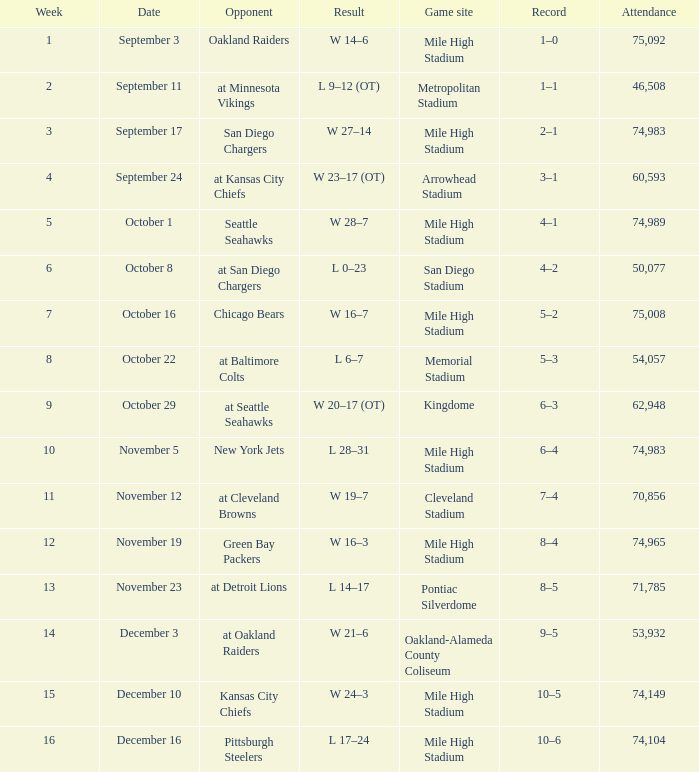In which week is there a record of 5 wins and 2 losses? 7.0. 